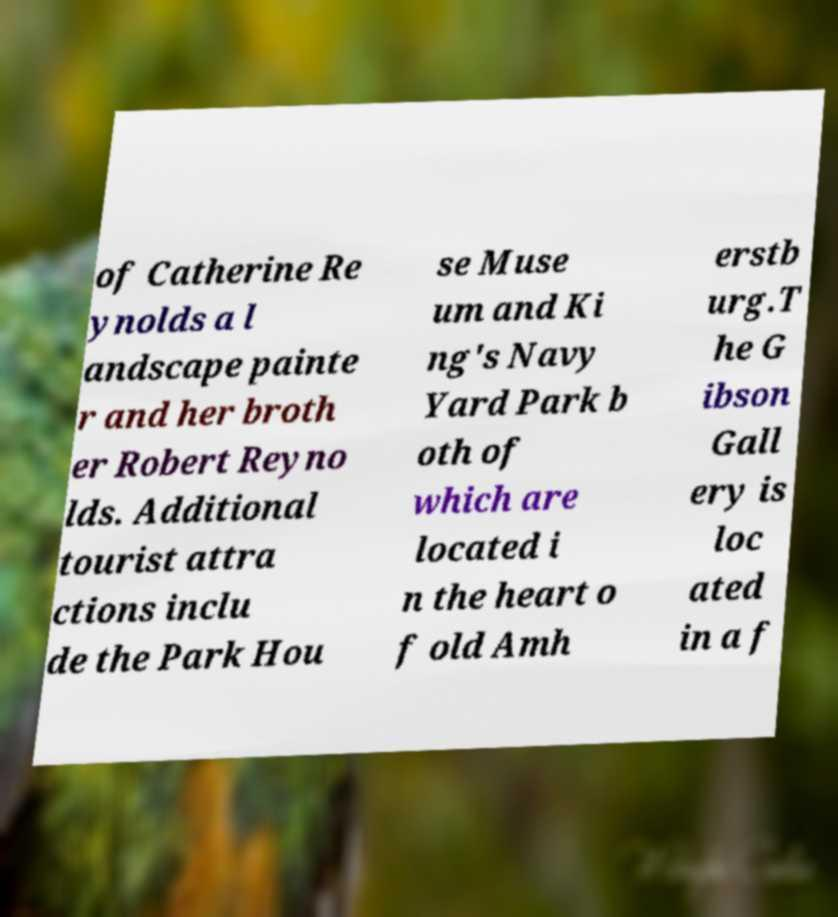Can you read and provide the text displayed in the image?This photo seems to have some interesting text. Can you extract and type it out for me? of Catherine Re ynolds a l andscape painte r and her broth er Robert Reyno lds. Additional tourist attra ctions inclu de the Park Hou se Muse um and Ki ng's Navy Yard Park b oth of which are located i n the heart o f old Amh erstb urg.T he G ibson Gall ery is loc ated in a f 